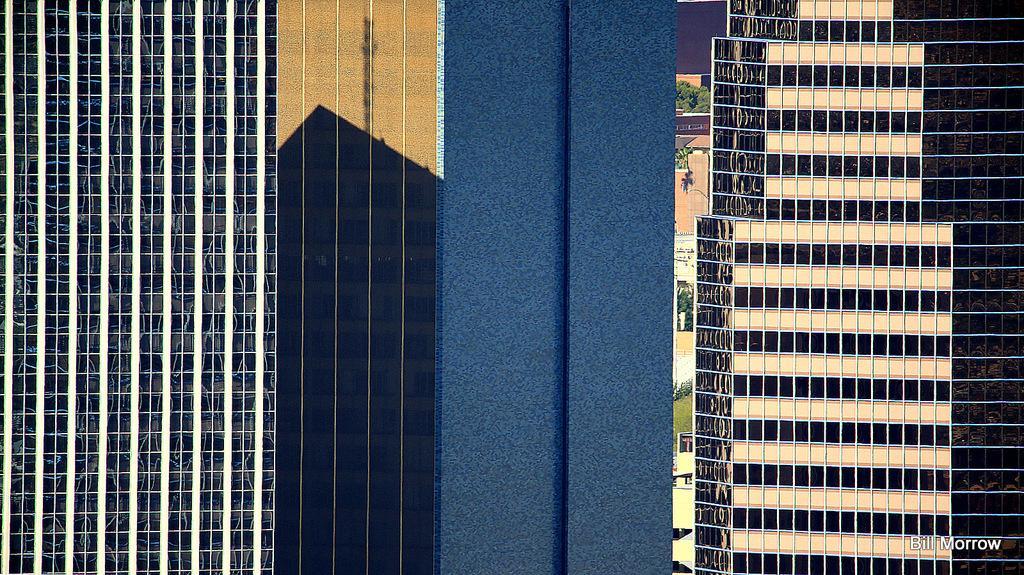How would you summarize this image in a sentence or two? In this image there are buildings. In the center there are plants and grass on the ground. In the bottom right there is text on the image. 